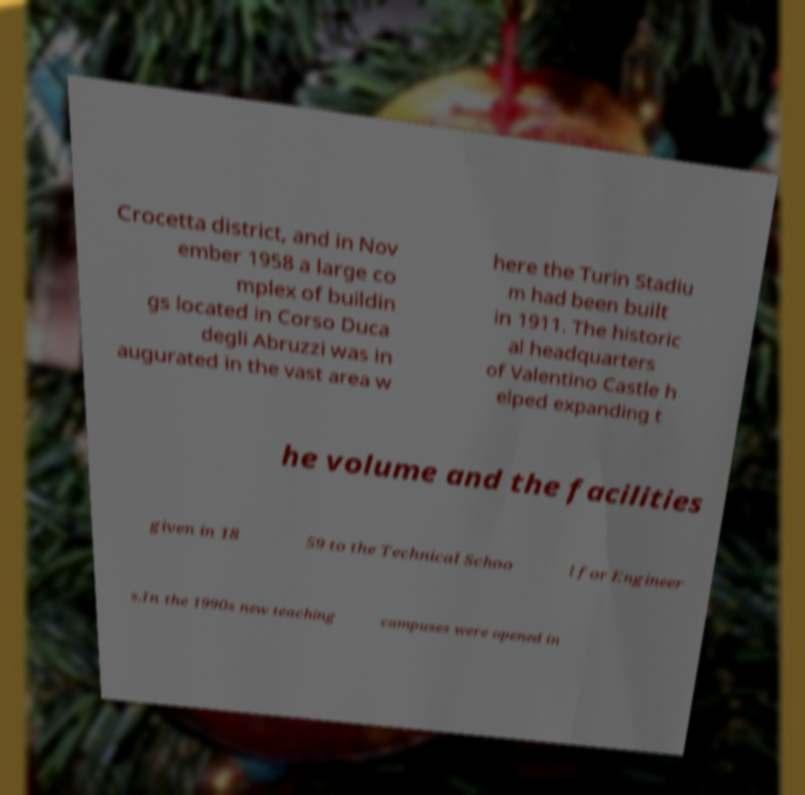Can you read and provide the text displayed in the image?This photo seems to have some interesting text. Can you extract and type it out for me? Crocetta district, and in Nov ember 1958 a large co mplex of buildin gs located in Corso Duca degli Abruzzi was in augurated in the vast area w here the Turin Stadiu m had been built in 1911. The historic al headquarters of Valentino Castle h elped expanding t he volume and the facilities given in 18 59 to the Technical Schoo l for Engineer s.In the 1990s new teaching campuses were opened in 